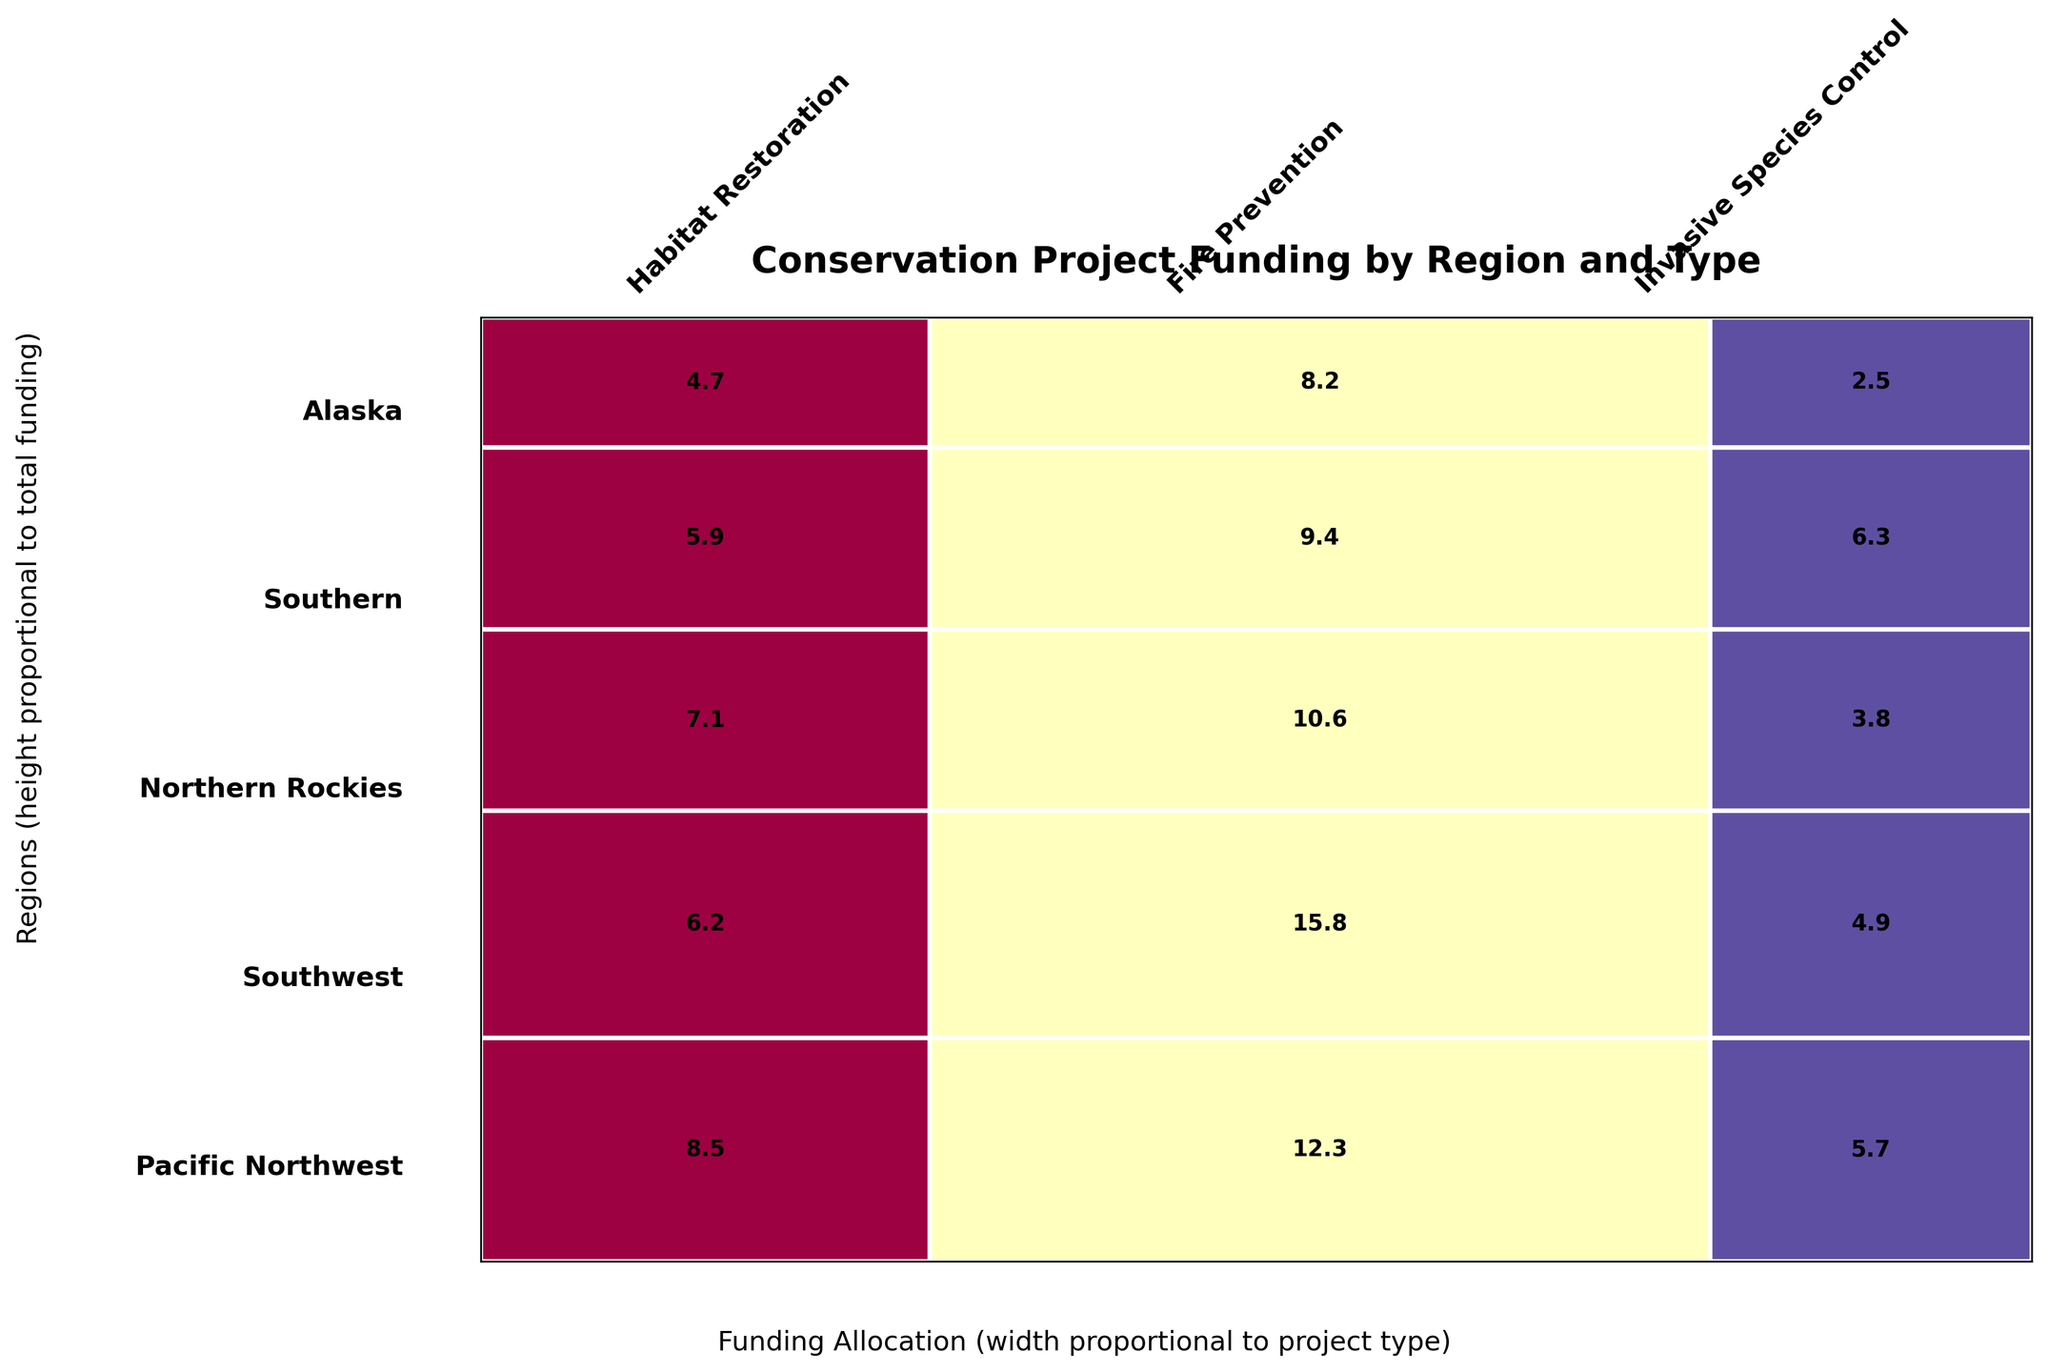What's the total funding allocated for the Pacific Northwest region? To find the total funding for the Pacific Northwest region, sum up the values for all project types within that region. The values are 8.5, 12.3, and 5.7. By adding these together (8.5 + 12.3 + 5.7), we get a total of 26.5 million dollars.
Answer: 26.5 Which region has the highest allocation for Fire Prevention projects? To determine which region has the highest funding for Fire Prevention, compare the Fire Prevention values for all regions. The values are as follows: Pacific Northwest (12.3), Southwest (15.8), Northern Rockies (10.6), Southern (9.4), and Alaska (8.2). The highest value is 15.8 in the Southwest region.
Answer: Southwest How does the funding for Invasive Species Control in the Southern region compare to that in the Pacific Northwest? The funding for Invasive Species Control in the Southern region is 6.3 million, whereas in the Pacific Northwest, it is 5.7 million. By comparing these values, 6.3 is greater than 5.7.
Answer: Southern has more What is the combined funding for Habitat Restoration and Fire Prevention projects in the Northern Rockies? To find the combined funding for these two project types in the Northern Rockies, add together their values: 7.1 (Habitat Restoration) + 10.6 (Fire Prevention) = 17.7 million dollars.
Answer: 17.7 Which project type received the least funding in the Alaska region? To find the project type with the least funding in the Alaska region, compare the values of all project types in that region: Habitat Restoration (4.7), Fire Prevention (8.2), and Invasive Species Control (2.5). The least value is 2.5, which corresponds to Invasive Species Control.
Answer: Invasive Species Control Which region has the most balanced funding distribution across project types? By analyzing the plot, observe regions where the funding rectangles for each project type are roughly equal in size. In this case, the Southern region shows a more balanced distribution compared to others, with more equal proportions for each project type (5.9 for Habitat Restoration, 9.4 for Fire Prevention, 6.3 for Invasive Species Control).
Answer: Southern What is the proportion of funding allocated to Fire Prevention projects in the Southwest compared to the total funding of that region? First, sum up the total funding for the Southwest region: 6.2 (Habitat Restoration) + 15.8 (Fire Prevention) + 4.9 (Invasive Species Control) = 26.9. Then, divide the Fire Prevention funding by the total funding: 15.8 / 26.9. This gives approximately 0.587, or 58.7%.
Answer: 58.7% Which region has the largest total funding for conservation projects? Sum up the total funding for each region and compare: Pacific Northwest (26.5), Southwest (26.9), Northern Rockies (21.5), Southern (21.6), and Alaska (15.4). The Southwest region has the largest total funding of 26.9 million dollars.
Answer: Southwest 